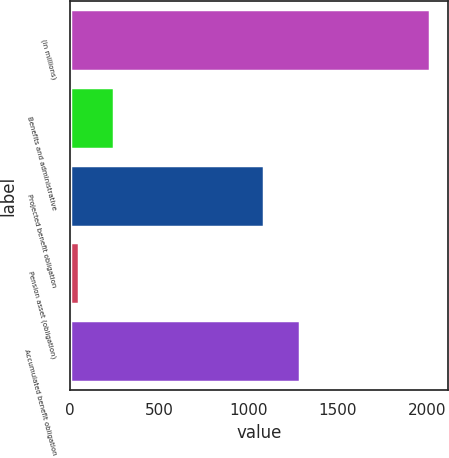Convert chart to OTSL. <chart><loc_0><loc_0><loc_500><loc_500><bar_chart><fcel>(in millions)<fcel>Benefits and administrative<fcel>Projected benefit obligation<fcel>Pension asset (obligation)<fcel>Accumulated benefit obligation<nl><fcel>2017<fcel>246.7<fcel>1089<fcel>50<fcel>1285.7<nl></chart> 